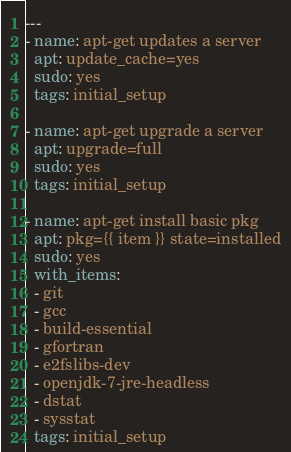Convert code to text. <code><loc_0><loc_0><loc_500><loc_500><_YAML_>---
- name: apt-get updates a server
  apt: update_cache=yes
  sudo: yes
  tags: initial_setup

- name: apt-get upgrade a server
  apt: upgrade=full
  sudo: yes
  tags: initial_setup

- name: apt-get install basic pkg
  apt: pkg={{ item }} state=installed
  sudo: yes
  with_items:
  - git
  - gcc
  - build-essential
  - gfortran
  - e2fslibs-dev
  - openjdk-7-jre-headless
  - dstat
  - sysstat
  tags: initial_setup

</code> 